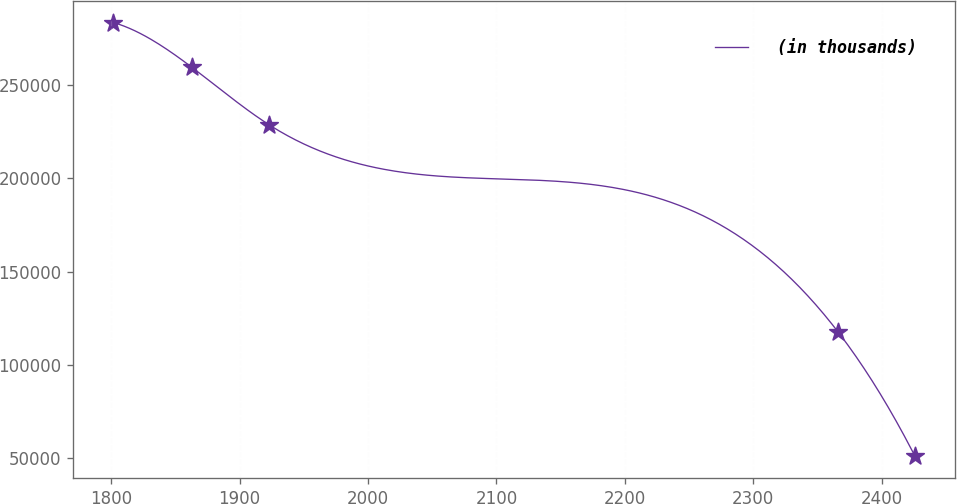Convert chart to OTSL. <chart><loc_0><loc_0><loc_500><loc_500><line_chart><ecel><fcel>(in thousands)<nl><fcel>1801.62<fcel>283708<nl><fcel>1862.92<fcel>259598<nl><fcel>1923.01<fcel>228773<nl><fcel>2366.04<fcel>117695<nl><fcel>2426.13<fcel>50780.8<nl></chart> 